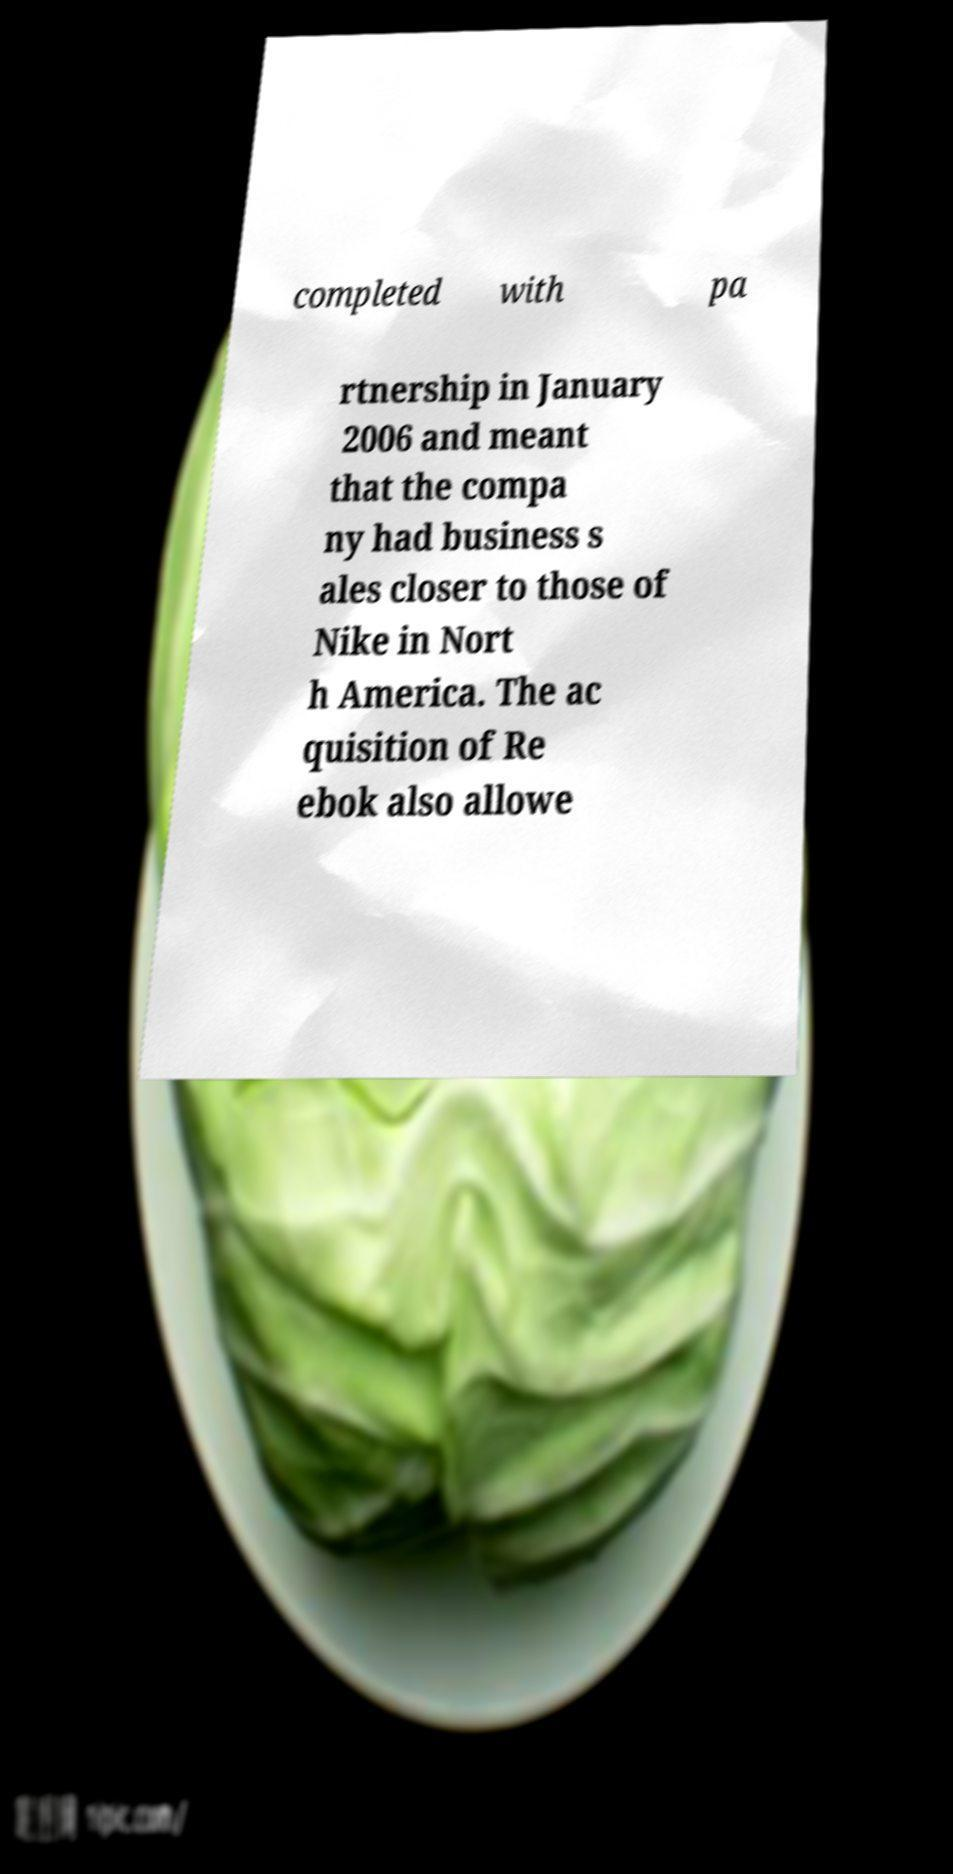There's text embedded in this image that I need extracted. Can you transcribe it verbatim? completed with pa rtnership in January 2006 and meant that the compa ny had business s ales closer to those of Nike in Nort h America. The ac quisition of Re ebok also allowe 